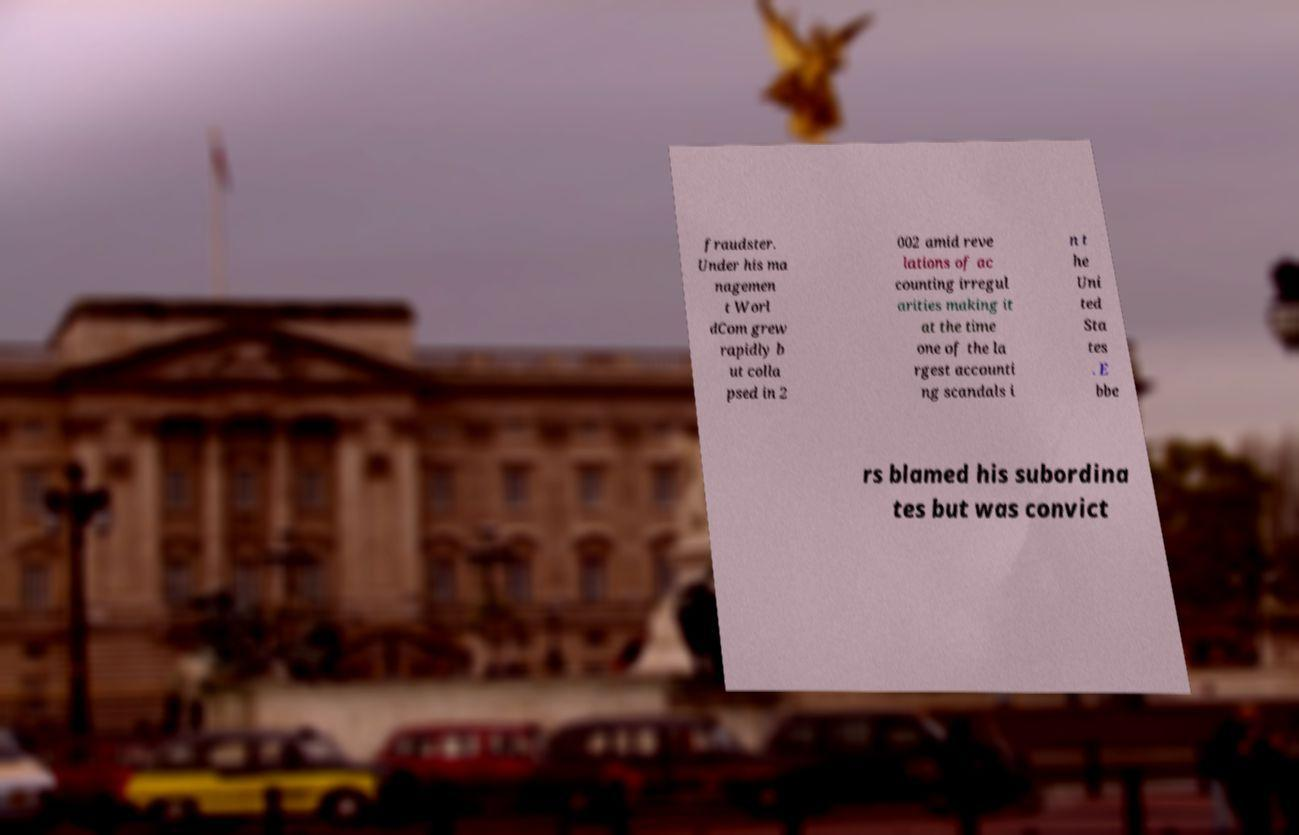Could you assist in decoding the text presented in this image and type it out clearly? fraudster. Under his ma nagemen t Worl dCom grew rapidly b ut colla psed in 2 002 amid reve lations of ac counting irregul arities making it at the time one of the la rgest accounti ng scandals i n t he Uni ted Sta tes . E bbe rs blamed his subordina tes but was convict 